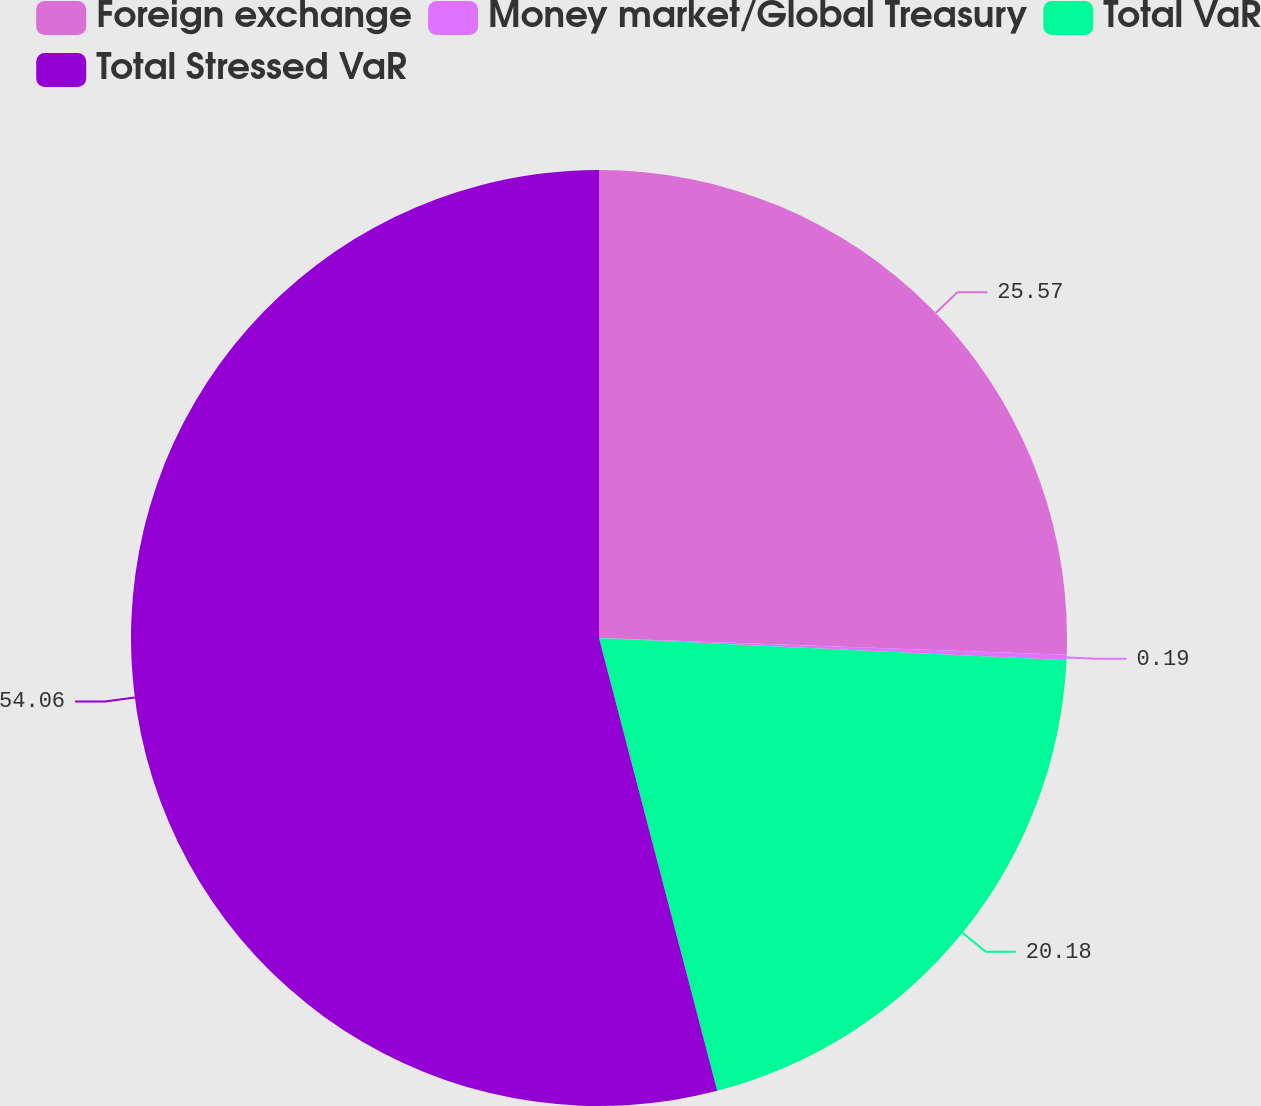Convert chart to OTSL. <chart><loc_0><loc_0><loc_500><loc_500><pie_chart><fcel>Foreign exchange<fcel>Money market/Global Treasury<fcel>Total VaR<fcel>Total Stressed VaR<nl><fcel>25.57%<fcel>0.19%<fcel>20.18%<fcel>54.07%<nl></chart> 